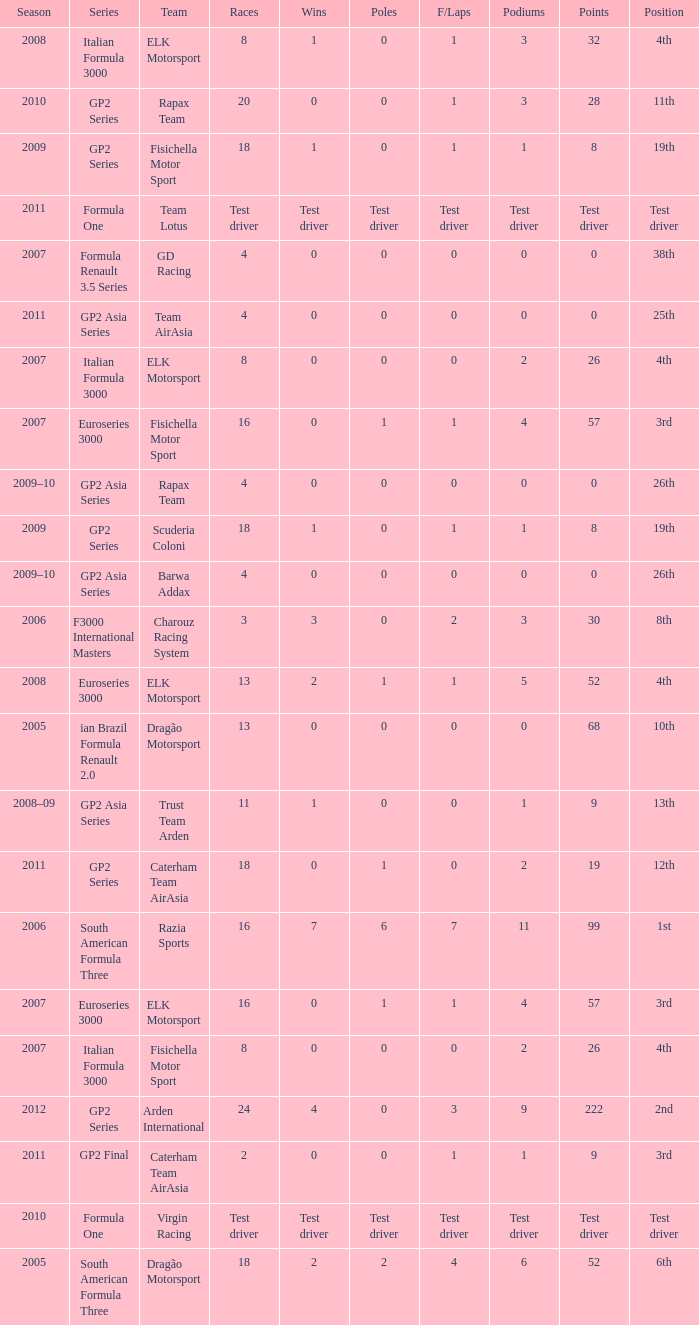How many races did he do in the year he had 8 points? 18, 18. I'm looking to parse the entire table for insights. Could you assist me with that? {'header': ['Season', 'Series', 'Team', 'Races', 'Wins', 'Poles', 'F/Laps', 'Podiums', 'Points', 'Position'], 'rows': [['2008', 'Italian Formula 3000', 'ELK Motorsport', '8', '1', '0', '1', '3', '32', '4th'], ['2010', 'GP2 Series', 'Rapax Team', '20', '0', '0', '1', '3', '28', '11th'], ['2009', 'GP2 Series', 'Fisichella Motor Sport', '18', '1', '0', '1', '1', '8', '19th'], ['2011', 'Formula One', 'Team Lotus', 'Test driver', 'Test driver', 'Test driver', 'Test driver', 'Test driver', 'Test driver', 'Test driver'], ['2007', 'Formula Renault 3.5 Series', 'GD Racing', '4', '0', '0', '0', '0', '0', '38th'], ['2011', 'GP2 Asia Series', 'Team AirAsia', '4', '0', '0', '0', '0', '0', '25th'], ['2007', 'Italian Formula 3000', 'ELK Motorsport', '8', '0', '0', '0', '2', '26', '4th'], ['2007', 'Euroseries 3000', 'Fisichella Motor Sport', '16', '0', '1', '1', '4', '57', '3rd'], ['2009–10', 'GP2 Asia Series', 'Rapax Team', '4', '0', '0', '0', '0', '0', '26th'], ['2009', 'GP2 Series', 'Scuderia Coloni', '18', '1', '0', '1', '1', '8', '19th'], ['2009–10', 'GP2 Asia Series', 'Barwa Addax', '4', '0', '0', '0', '0', '0', '26th'], ['2006', 'F3000 International Masters', 'Charouz Racing System', '3', '3', '0', '2', '3', '30', '8th'], ['2008', 'Euroseries 3000', 'ELK Motorsport', '13', '2', '1', '1', '5', '52', '4th'], ['2005', 'ian Brazil Formula Renault 2.0', 'Dragão Motorsport', '13', '0', '0', '0', '0', '68', '10th'], ['2008–09', 'GP2 Asia Series', 'Trust Team Arden', '11', '1', '0', '0', '1', '9', '13th'], ['2011', 'GP2 Series', 'Caterham Team AirAsia', '18', '0', '1', '0', '2', '19', '12th'], ['2006', 'South American Formula Three', 'Razia Sports', '16', '7', '6', '7', '11', '99', '1st'], ['2007', 'Euroseries 3000', 'ELK Motorsport', '16', '0', '1', '1', '4', '57', '3rd'], ['2007', 'Italian Formula 3000', 'Fisichella Motor Sport', '8', '0', '0', '0', '2', '26', '4th'], ['2012', 'GP2 Series', 'Arden International', '24', '4', '0', '3', '9', '222', '2nd'], ['2011', 'GP2 Final', 'Caterham Team AirAsia', '2', '0', '0', '1', '1', '9', '3rd'], ['2010', 'Formula One', 'Virgin Racing', 'Test driver', 'Test driver', 'Test driver', 'Test driver', 'Test driver', 'Test driver', 'Test driver'], ['2005', 'South American Formula Three', 'Dragão Motorsport', '18', '2', '2', '4', '6', '52', '6th']]} 